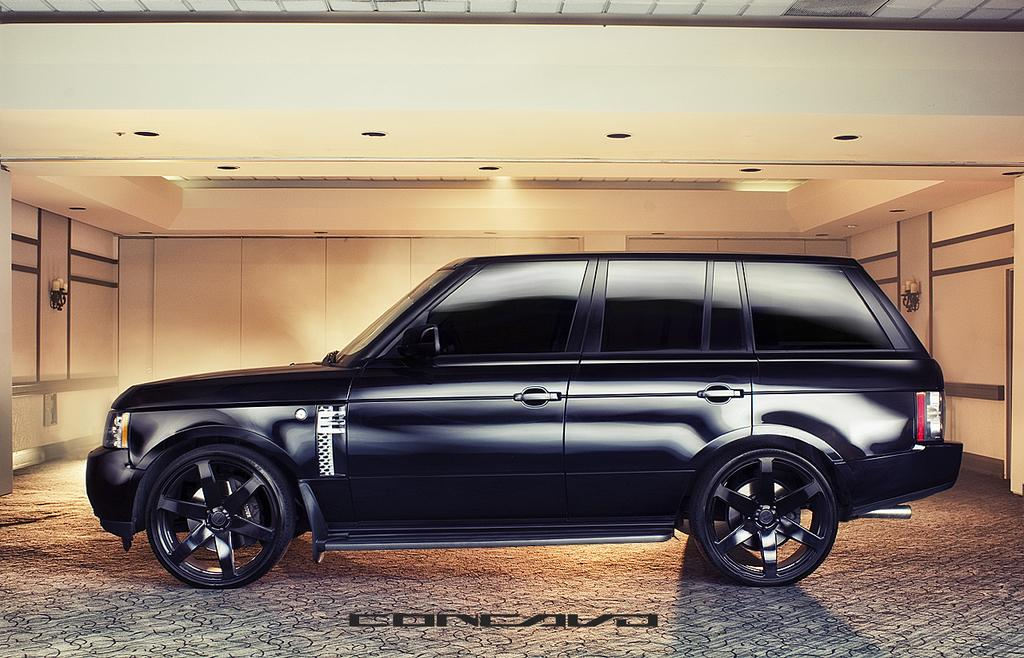What is the main subject in the middle of the image? There is a car in the middle of the image. What can be found at the bottom of the image? There is text at the bottom of the image. What type of lighting is visible at the top of the image? There are ceiling lights at the top of the image. Has the image been altered in any way? Yes, the image has been edited. How many yams are floating in the waves in the image? There are no yams or waves present in the image. 